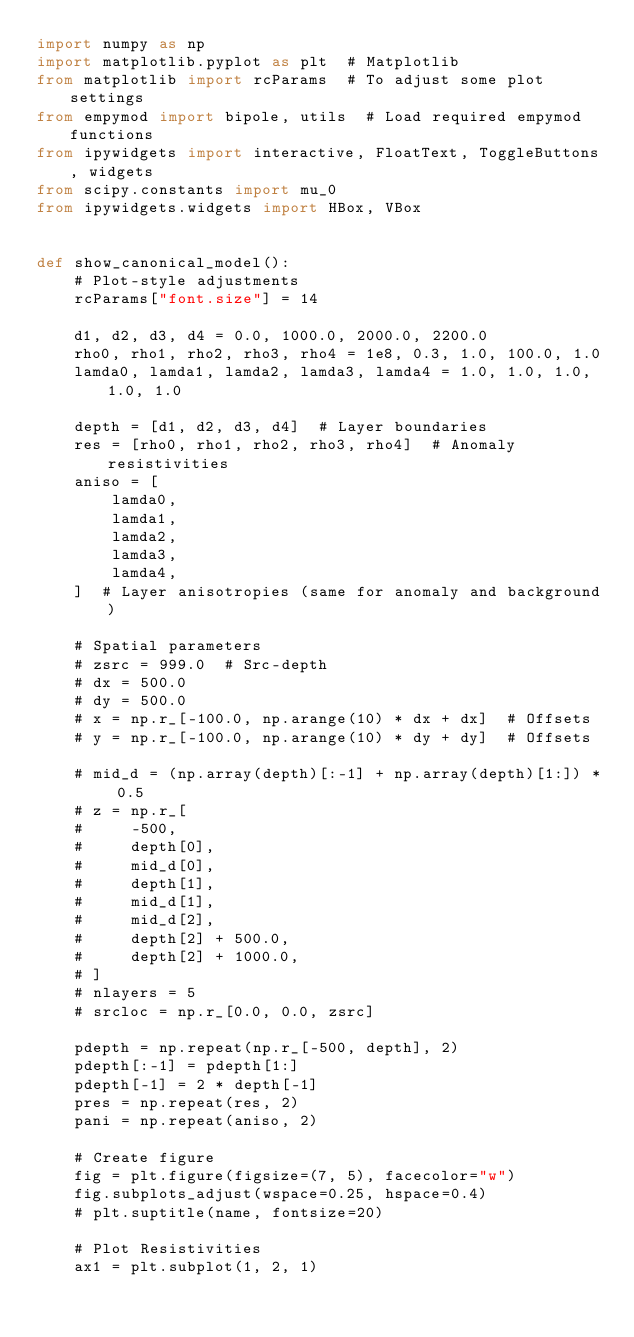Convert code to text. <code><loc_0><loc_0><loc_500><loc_500><_Python_>import numpy as np
import matplotlib.pyplot as plt  # Matplotlib
from matplotlib import rcParams  # To adjust some plot settings
from empymod import bipole, utils  # Load required empymod functions
from ipywidgets import interactive, FloatText, ToggleButtons, widgets
from scipy.constants import mu_0
from ipywidgets.widgets import HBox, VBox


def show_canonical_model():
    # Plot-style adjustments
    rcParams["font.size"] = 14

    d1, d2, d3, d4 = 0.0, 1000.0, 2000.0, 2200.0
    rho0, rho1, rho2, rho3, rho4 = 1e8, 0.3, 1.0, 100.0, 1.0
    lamda0, lamda1, lamda2, lamda3, lamda4 = 1.0, 1.0, 1.0, 1.0, 1.0

    depth = [d1, d2, d3, d4]  # Layer boundaries
    res = [rho0, rho1, rho2, rho3, rho4]  # Anomaly resistivities
    aniso = [
        lamda0,
        lamda1,
        lamda2,
        lamda3,
        lamda4,
    ]  # Layer anisotropies (same for anomaly and background)

    # Spatial parameters
    # zsrc = 999.0  # Src-depth
    # dx = 500.0
    # dy = 500.0
    # x = np.r_[-100.0, np.arange(10) * dx + dx]  # Offsets
    # y = np.r_[-100.0, np.arange(10) * dy + dy]  # Offsets

    # mid_d = (np.array(depth)[:-1] + np.array(depth)[1:]) * 0.5
    # z = np.r_[
    #     -500,
    #     depth[0],
    #     mid_d[0],
    #     depth[1],
    #     mid_d[1],
    #     mid_d[2],
    #     depth[2] + 500.0,
    #     depth[2] + 1000.0,
    # ]
    # nlayers = 5
    # srcloc = np.r_[0.0, 0.0, zsrc]

    pdepth = np.repeat(np.r_[-500, depth], 2)
    pdepth[:-1] = pdepth[1:]
    pdepth[-1] = 2 * depth[-1]
    pres = np.repeat(res, 2)
    pani = np.repeat(aniso, 2)

    # Create figure
    fig = plt.figure(figsize=(7, 5), facecolor="w")
    fig.subplots_adjust(wspace=0.25, hspace=0.4)
    # plt.suptitle(name, fontsize=20)

    # Plot Resistivities
    ax1 = plt.subplot(1, 2, 1)</code> 